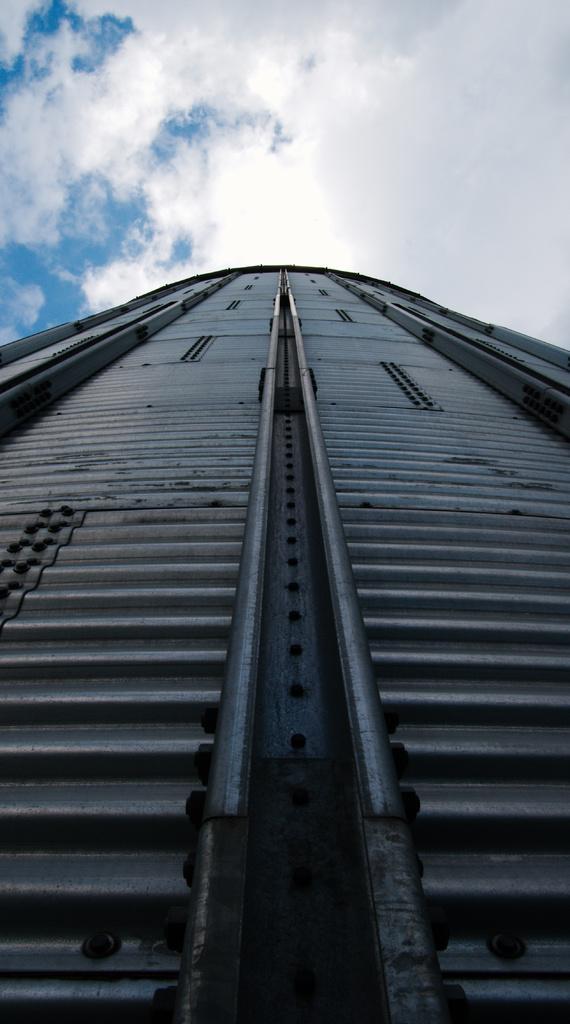Could you give a brief overview of what you see in this image? In this picture we can see under construction bridge and clouded sky. 